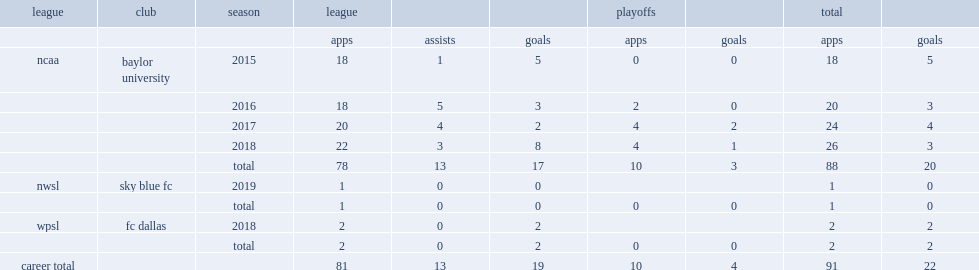Which season did james play in the nwsl for sky blue fc? 2019.0. 